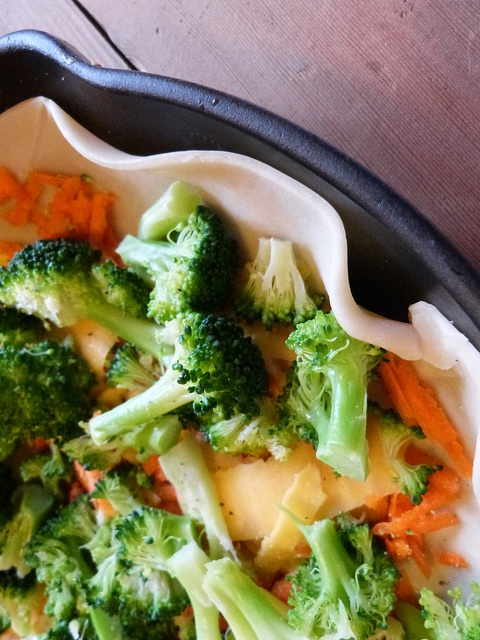Describe the objects in this image and their specific colors. I can see dining table in black, lightgray, darkgray, and olive tones, bowl in lavender, black, lightgray, and olive tones, bowl in lavender, black, and gray tones, broccoli in lavender, black, darkgreen, and olive tones, and broccoli in lavender, olive, and lightgreen tones in this image. 